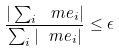Convert formula to latex. <formula><loc_0><loc_0><loc_500><loc_500>\frac { | \sum _ { i } \ m e _ { i } | } { \sum _ { i } | \ m e _ { i } | } \leq \epsilon</formula> 